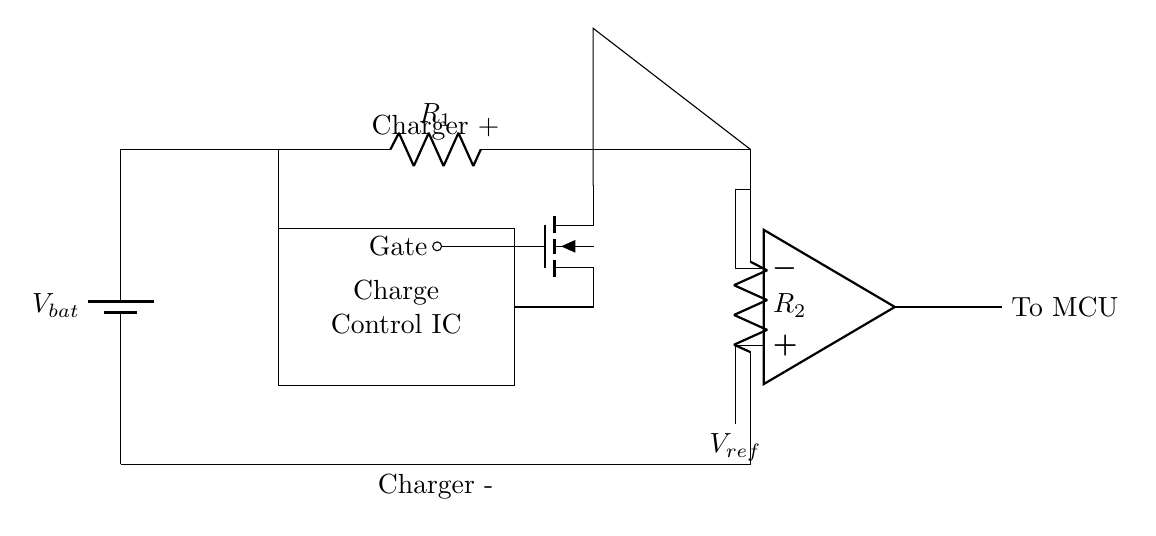What is the function of the Charge Control IC? The Charge Control IC regulates the charging process to prevent overcharging of the battery.
Answer: Regulates charging What are the components used in this circuit? The components in the circuit include a battery, Charge Control IC, MOSFET, resistors, and a comparator.
Answer: Battery, Charge Control IC, MOSFET, resistors, comparator What does the voltage divider consist of? The voltage divider consists of two resistors, R1 and R2, connected in series.
Answer: R1 and R2 What is the role of the MOSFET in this circuit? The MOSFET acts as a switch that controls the flow of current based on the gate voltage from the Charge Control IC.
Answer: Acts as a switch What determines the reference voltage in this circuit? The reference voltage is determined by the potential difference created by the voltage divider, specifically across R2.
Answer: Voltage divider What happens if the voltage exceeds the reference voltage? If the battery voltage exceeds the reference voltage, the output of the comparator will change state, signaling the MOSFET to turn off and stop charging.
Answer: MOSFET turns off How does the comparator determine when to send a signal to the MCU? The comparator compares the battery voltage (after the voltage divider) to the reference voltage and sends a signal to the MCU when the battery is overcharged.
Answer: Compares and signals 